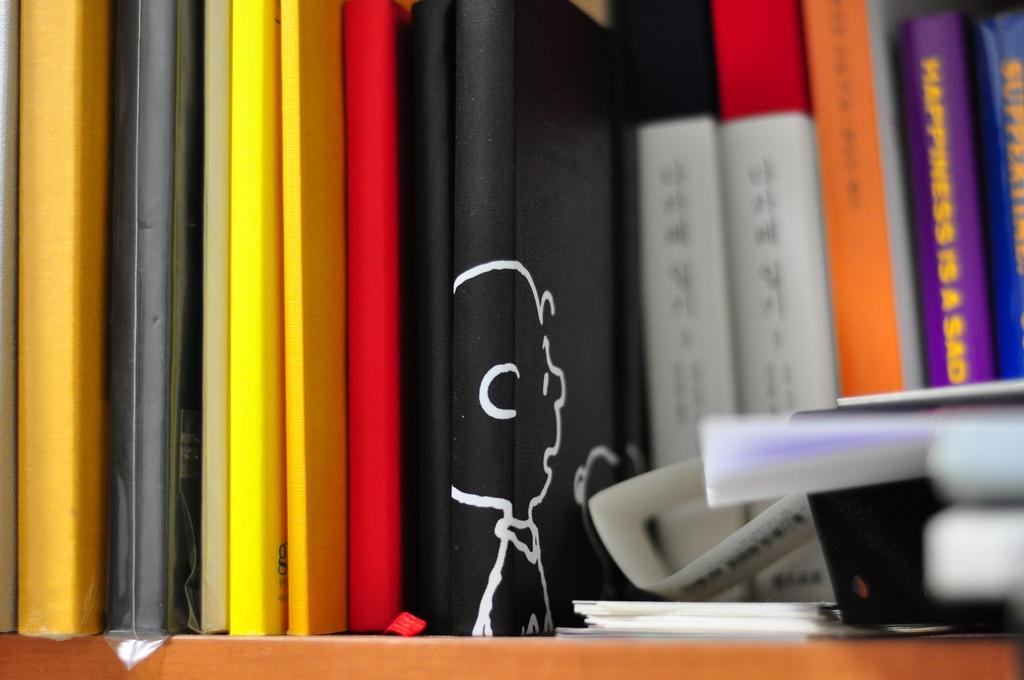What is the main subject of the image? The main subject of the image is a group of books. What is the surface made of that the books are resting on? The books are on a wooden surface. Are there any other objects visible in the image besides the books? Yes, there are a few objects on the right side of the image. What is the weight of the wooden town in the image? There is no wooden town present in the image, so it is not possible to determine its weight. 